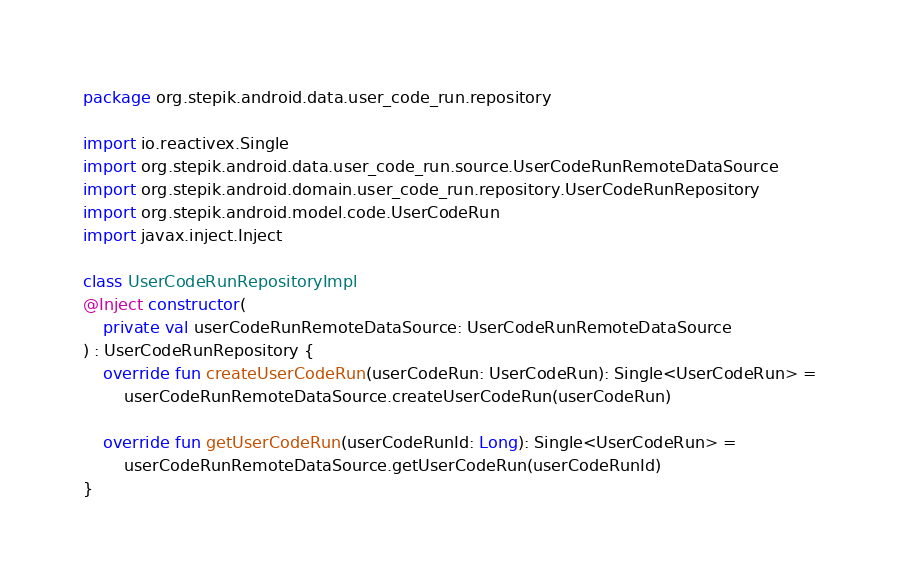Convert code to text. <code><loc_0><loc_0><loc_500><loc_500><_Kotlin_>package org.stepik.android.data.user_code_run.repository

import io.reactivex.Single
import org.stepik.android.data.user_code_run.source.UserCodeRunRemoteDataSource
import org.stepik.android.domain.user_code_run.repository.UserCodeRunRepository
import org.stepik.android.model.code.UserCodeRun
import javax.inject.Inject

class UserCodeRunRepositoryImpl
@Inject constructor(
    private val userCodeRunRemoteDataSource: UserCodeRunRemoteDataSource
) : UserCodeRunRepository {
    override fun createUserCodeRun(userCodeRun: UserCodeRun): Single<UserCodeRun> =
        userCodeRunRemoteDataSource.createUserCodeRun(userCodeRun)

    override fun getUserCodeRun(userCodeRunId: Long): Single<UserCodeRun> =
        userCodeRunRemoteDataSource.getUserCodeRun(userCodeRunId)
}</code> 